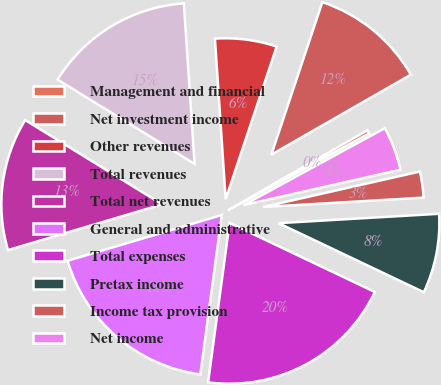Convert chart. <chart><loc_0><loc_0><loc_500><loc_500><pie_chart><fcel>Management and financial<fcel>Net investment income<fcel>Other revenues<fcel>Total revenues<fcel>Total net revenues<fcel>General and administrative<fcel>Total expenses<fcel>Pretax income<fcel>Income tax provision<fcel>Net income<nl><fcel>0.35%<fcel>11.58%<fcel>6.2%<fcel>15.16%<fcel>13.37%<fcel>18.28%<fcel>20.07%<fcel>7.99%<fcel>2.61%<fcel>4.4%<nl></chart> 